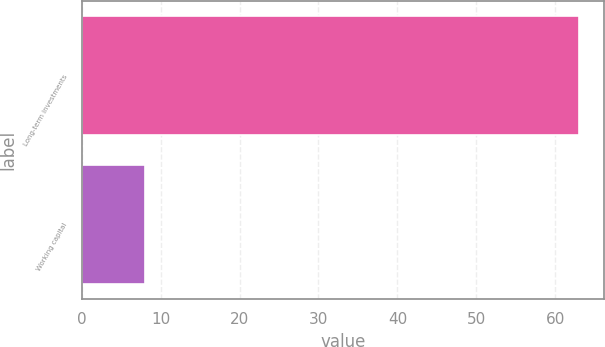Convert chart. <chart><loc_0><loc_0><loc_500><loc_500><bar_chart><fcel>Long-term investments<fcel>Working capital<nl><fcel>63<fcel>8<nl></chart> 